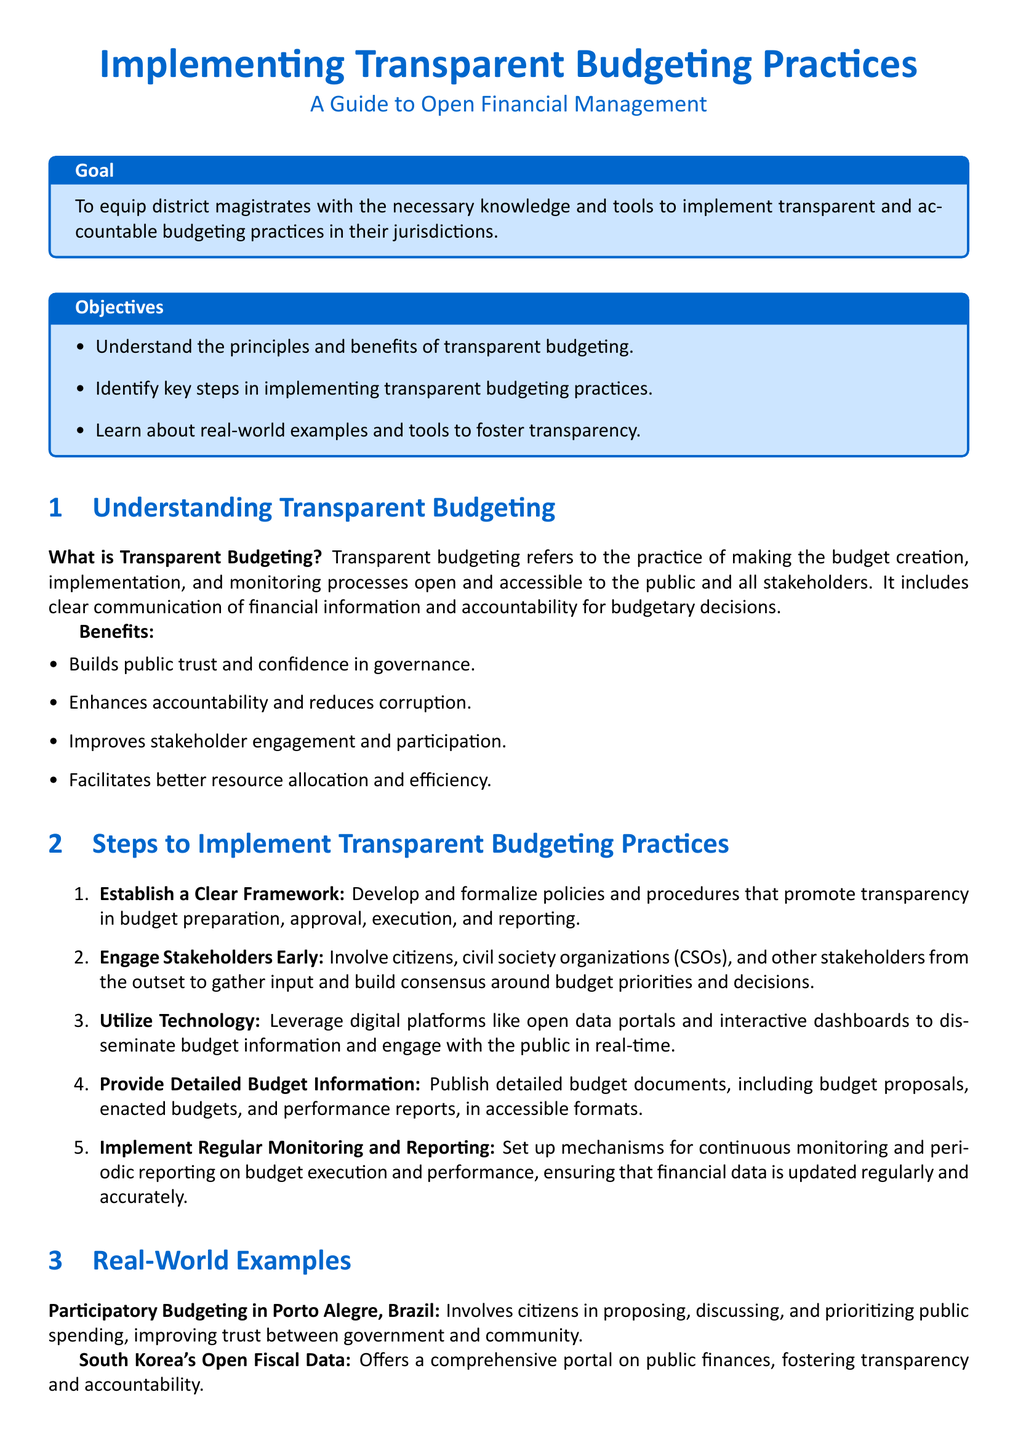What is the goal of the lesson plan? The goal is to equip district magistrates with the necessary knowledge and tools to implement transparent and accountable budgeting practices.
Answer: To equip district magistrates with the necessary knowledge and tools to implement transparent and accountable budgeting practices What are the benefits of transparent budgeting? The benefits include building public trust and confidence, enhancing accountability, improving stakeholder engagement, and facilitating better resource allocation.
Answer: Builds public trust and confidence in governance, enhances accountability, improves stakeholder engagement and participation, facilitates better resource allocation and efficiency How many steps are outlined to implement transparent budgeting practices? The document lists five key steps for implementing transparent budgeting practices.
Answer: Five Which city is mentioned as an example of participatory budgeting? Porto Alegre in Brazil is specifically mentioned as an example of participatory budgeting.
Answer: Porto Alegre, Brazil What tool evaluates government budget transparency worldwide? The Open Budget Survey (OBS) evaluates government budget transparency worldwide.
Answer: Open Budget Survey (OBS) What action is suggested for engaging stakeholders? The recommended action is to involve citizens, civil society organizations, and other stakeholders from the outset.
Answer: Involve citizens, civil society organizations (CSOs), and other stakeholders from the outset What is one method to utilize technology in budgeting? The document suggests leveraging digital platforms like open data portals and interactive dashboards.
Answer: Digital platforms like open data portals and interactive dashboards What is the main focus of the document type? The main focus of the document is on implementing transparent budgeting practices.
Answer: Implementing transparent budgeting practices 